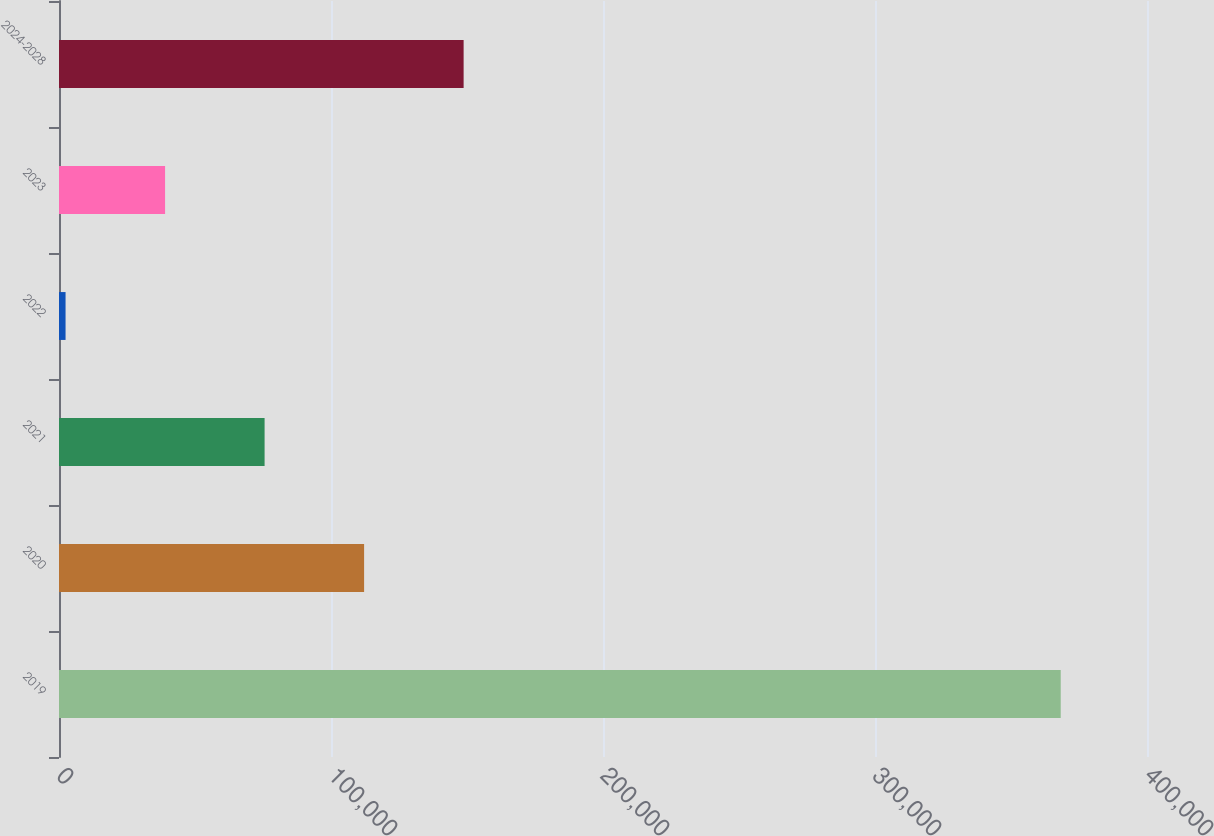Convert chart. <chart><loc_0><loc_0><loc_500><loc_500><bar_chart><fcel>2019<fcel>2020<fcel>2021<fcel>2022<fcel>2023<fcel>2024-2028<nl><fcel>368278<fcel>112170<fcel>75583.6<fcel>2410<fcel>38996.8<fcel>148757<nl></chart> 